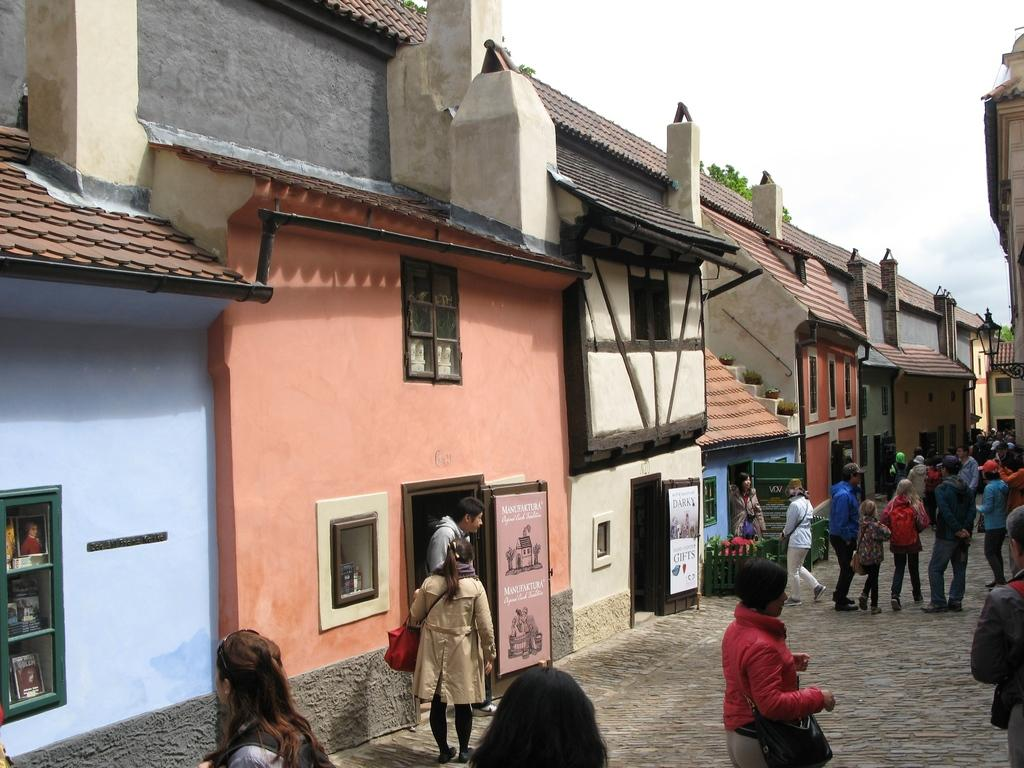What type of structures can be seen in the image? There are houses in the image. What else can be seen in the image besides houses? There are hoardings, a lamp, people on a path, trees, and the sky visible in the image. Can you describe the lighting source in the image? There is a lamp in the image. What type of vegetation is present in the image? There are trees in the image. What is visible at the top of the image? The sky is visible in the image. What channel is the wind tuned to in the image? There is no mention of wind or a channel in the image; it features houses, hoardings, a lamp, people on a path, trees, and the sky. 